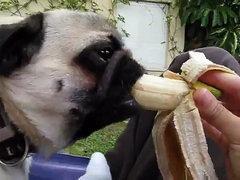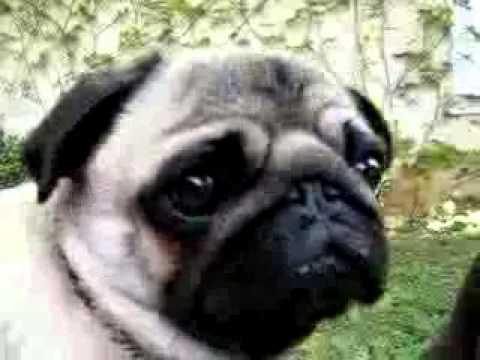The first image is the image on the left, the second image is the image on the right. Given the left and right images, does the statement "The dog in the image on the right is being offered a banana." hold true? Answer yes or no. No. The first image is the image on the left, the second image is the image on the right. Considering the images on both sides, is "All dogs shown are outdoors, and a hand is visible reaching from the right to offer a pug a banana in one image." valid? Answer yes or no. Yes. 